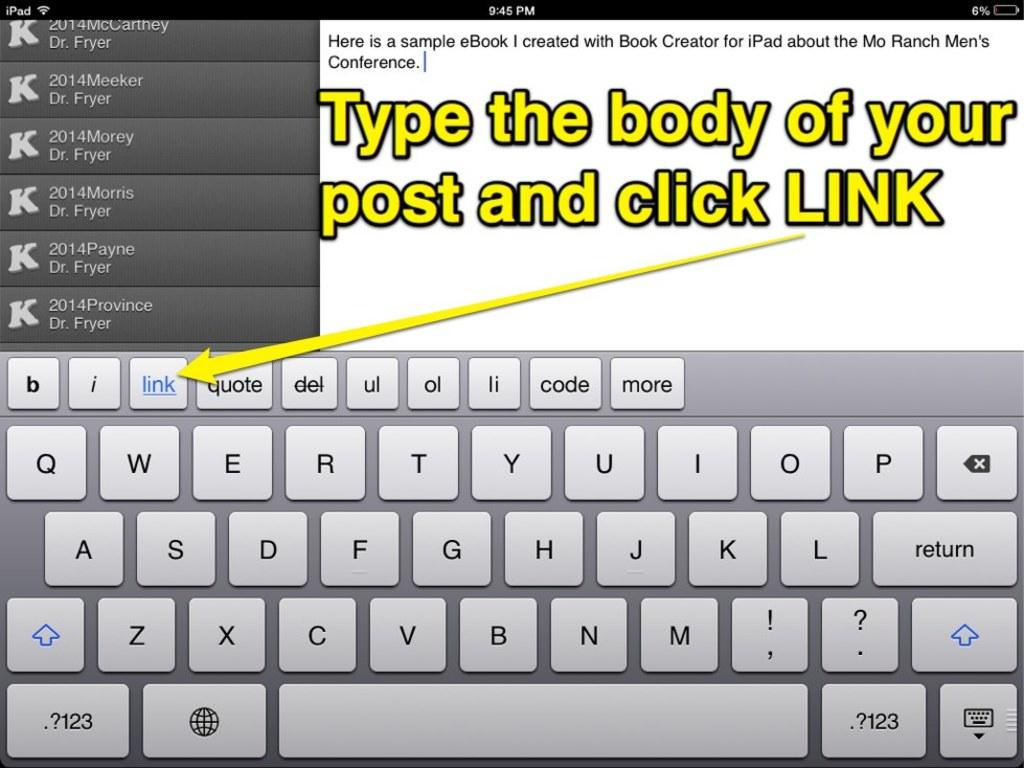What does it tell you to click?
Give a very brief answer. Link. Where is the return key?
Give a very brief answer. Answering does not require reading text in the image. 